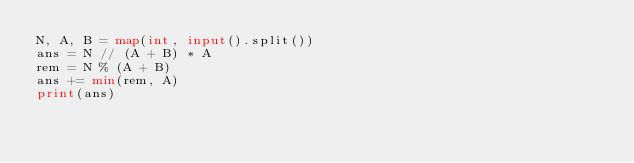<code> <loc_0><loc_0><loc_500><loc_500><_Python_>N, A, B = map(int, input().split())
ans = N // (A + B) * A
rem = N % (A + B)
ans += min(rem, A)
print(ans)
</code> 